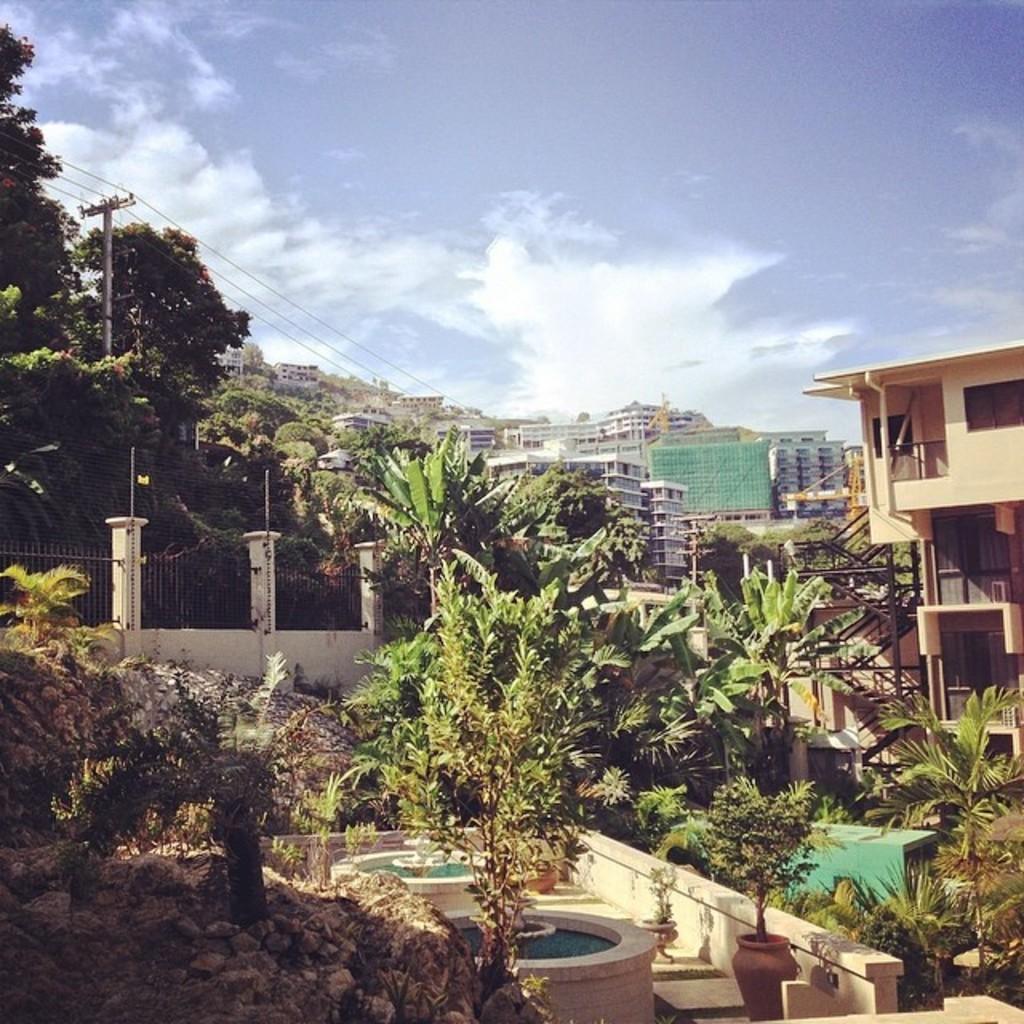Please provide a concise description of this image. In the picture I can see trees, fence, plants, plant pots and poles which has wires. In the background I can see buildings and the sky. 